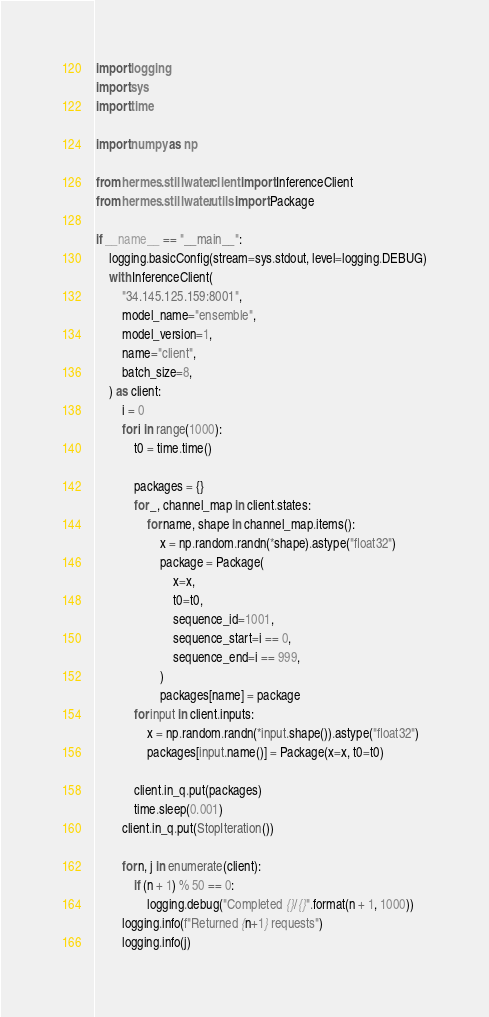Convert code to text. <code><loc_0><loc_0><loc_500><loc_500><_Python_>import logging
import sys
import time

import numpy as np

from hermes.stillwater.client import InferenceClient
from hermes.stillwater.utils import Package

if __name__ == "__main__":
    logging.basicConfig(stream=sys.stdout, level=logging.DEBUG)
    with InferenceClient(
        "34.145.125.159:8001",
        model_name="ensemble",
        model_version=1,
        name="client",
        batch_size=8,
    ) as client:
        i = 0
        for i in range(1000):
            t0 = time.time()

            packages = {}
            for _, channel_map in client.states:
                for name, shape in channel_map.items():
                    x = np.random.randn(*shape).astype("float32")
                    package = Package(
                        x=x,
                        t0=t0,
                        sequence_id=1001,
                        sequence_start=i == 0,
                        sequence_end=i == 999,
                    )
                    packages[name] = package
            for input in client.inputs:
                x = np.random.randn(*input.shape()).astype("float32")
                packages[input.name()] = Package(x=x, t0=t0)

            client.in_q.put(packages)
            time.sleep(0.001)
        client.in_q.put(StopIteration())

        for n, j in enumerate(client):
            if (n + 1) % 50 == 0:
                logging.debug("Completed {}/{}".format(n + 1, 1000))
        logging.info(f"Returned {n+1} requests")
        logging.info(j)
</code> 